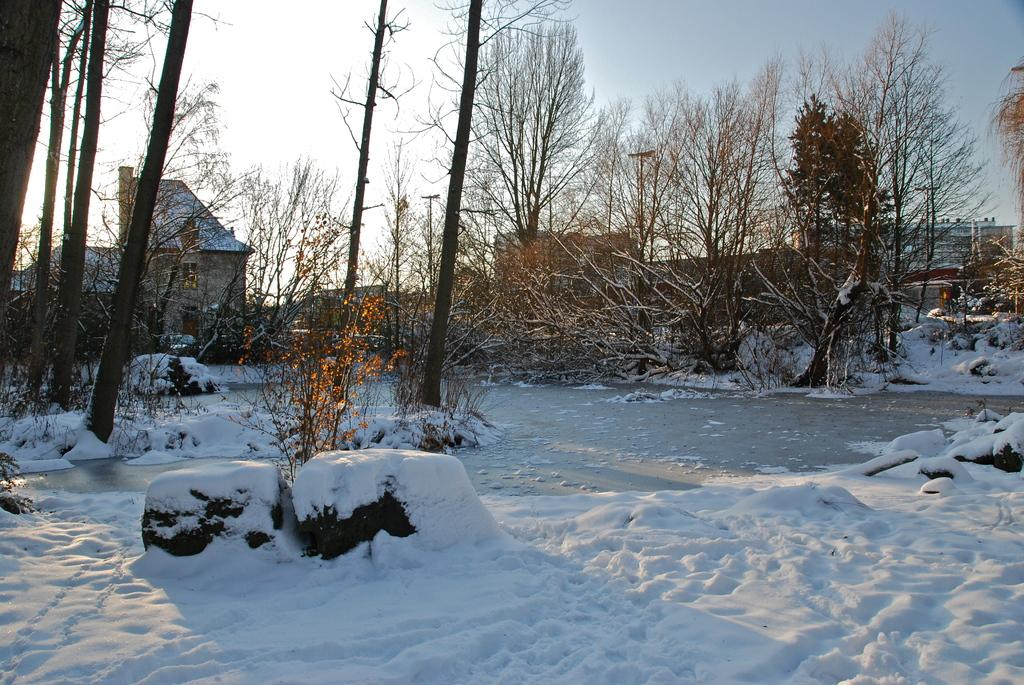What type of vegetation is present in the image? There are many trees in the image. What is covering the ground in the image? Snow is present on the ground. What else can be seen on the ground in the image? Stones are visible on the ground. What can be seen in the background of the image? There is a street light, poles, and buildings in the background. What is visible at the top of the image? The sky is visible at the top of the image. What is the interest rate on the silver coins in the image? There are no silver coins present in the image. What time of day is depicted in the image? The provided facts do not mention the time of day, so it cannot be determined from the image. 